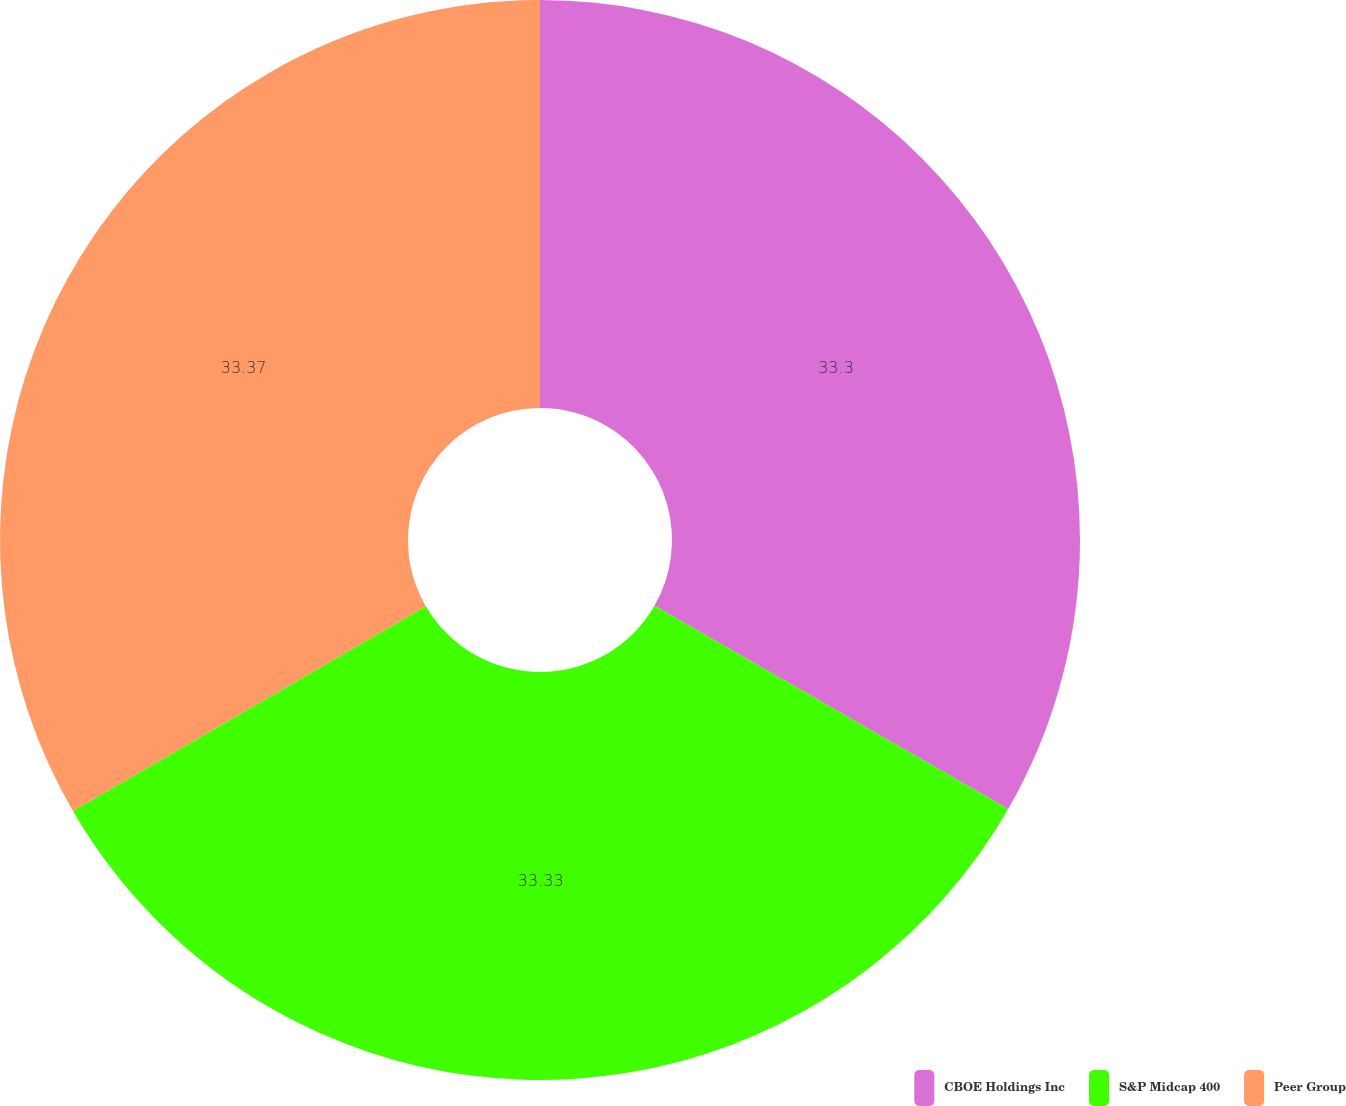Convert chart. <chart><loc_0><loc_0><loc_500><loc_500><pie_chart><fcel>CBOE Holdings Inc<fcel>S&P Midcap 400<fcel>Peer Group<nl><fcel>33.3%<fcel>33.33%<fcel>33.37%<nl></chart> 